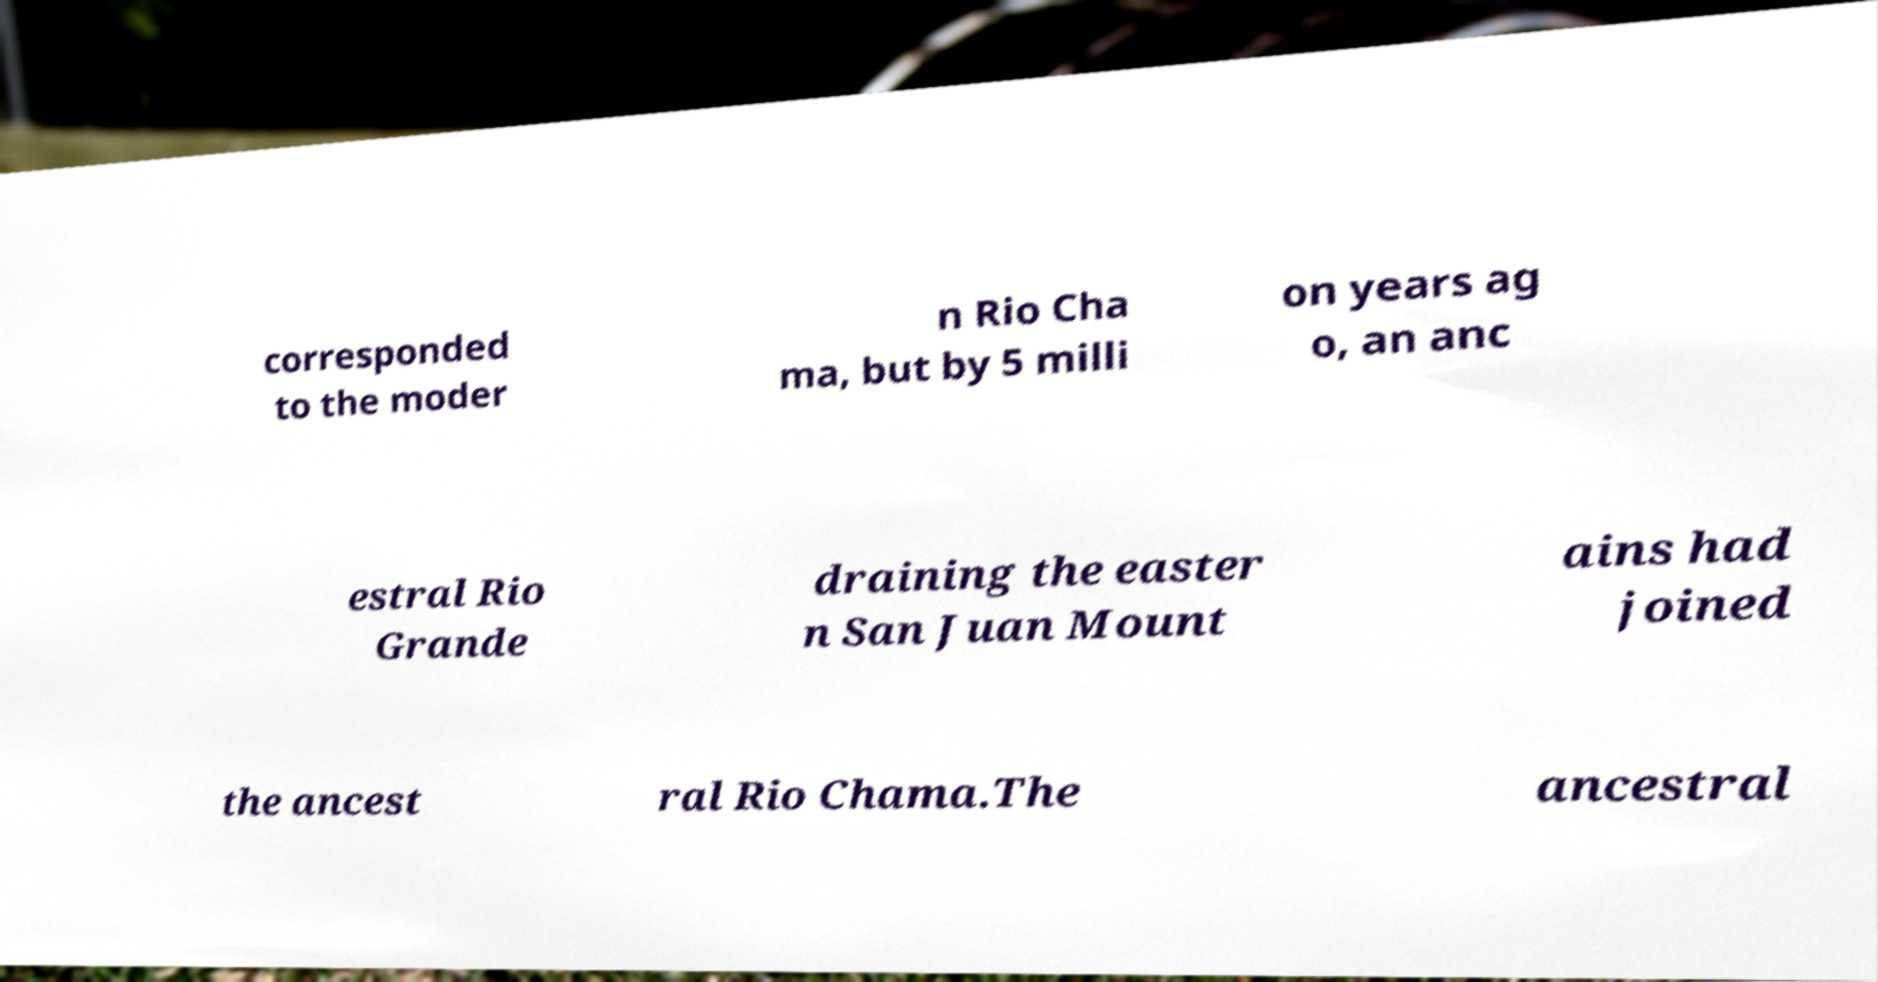There's text embedded in this image that I need extracted. Can you transcribe it verbatim? corresponded to the moder n Rio Cha ma, but by 5 milli on years ag o, an anc estral Rio Grande draining the easter n San Juan Mount ains had joined the ancest ral Rio Chama.The ancestral 